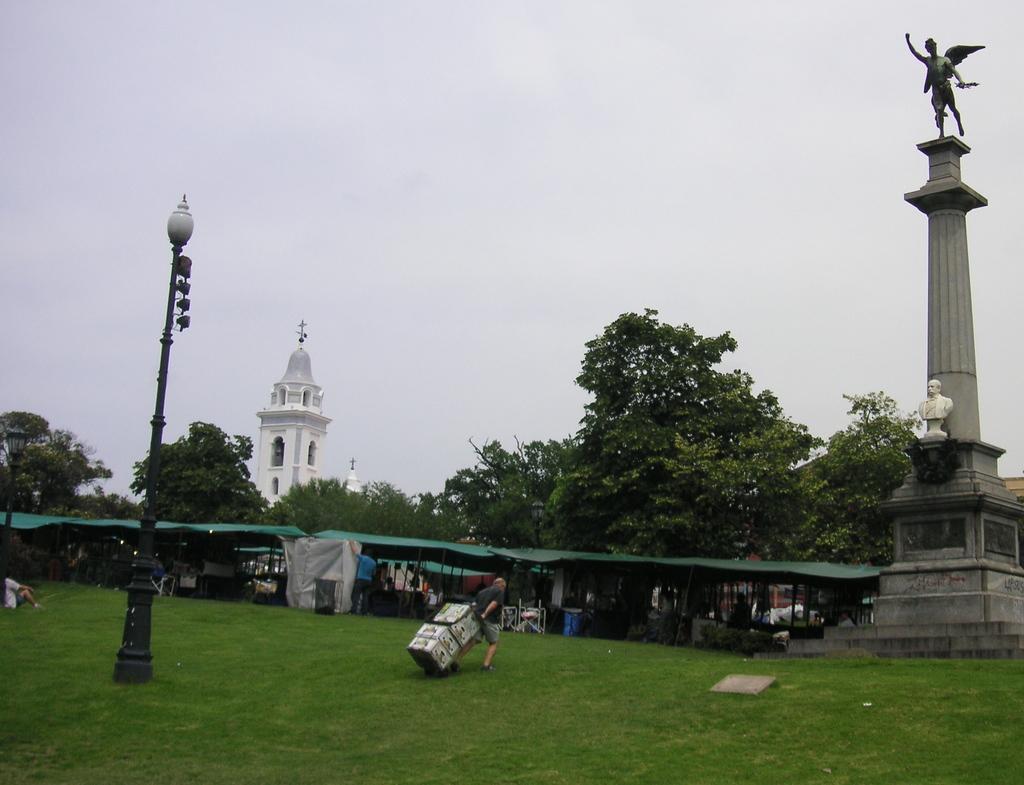Describe this image in one or two sentences. In this picture there are statues on the pillar on the right side of the image and there is grassland at the bottom side of the image, there is a lamp pole on the left side of the image, there are sheds in the center of the image, there are trees and a church in the background area of the image, there is a man who is carrying boxes in the center of the image. 